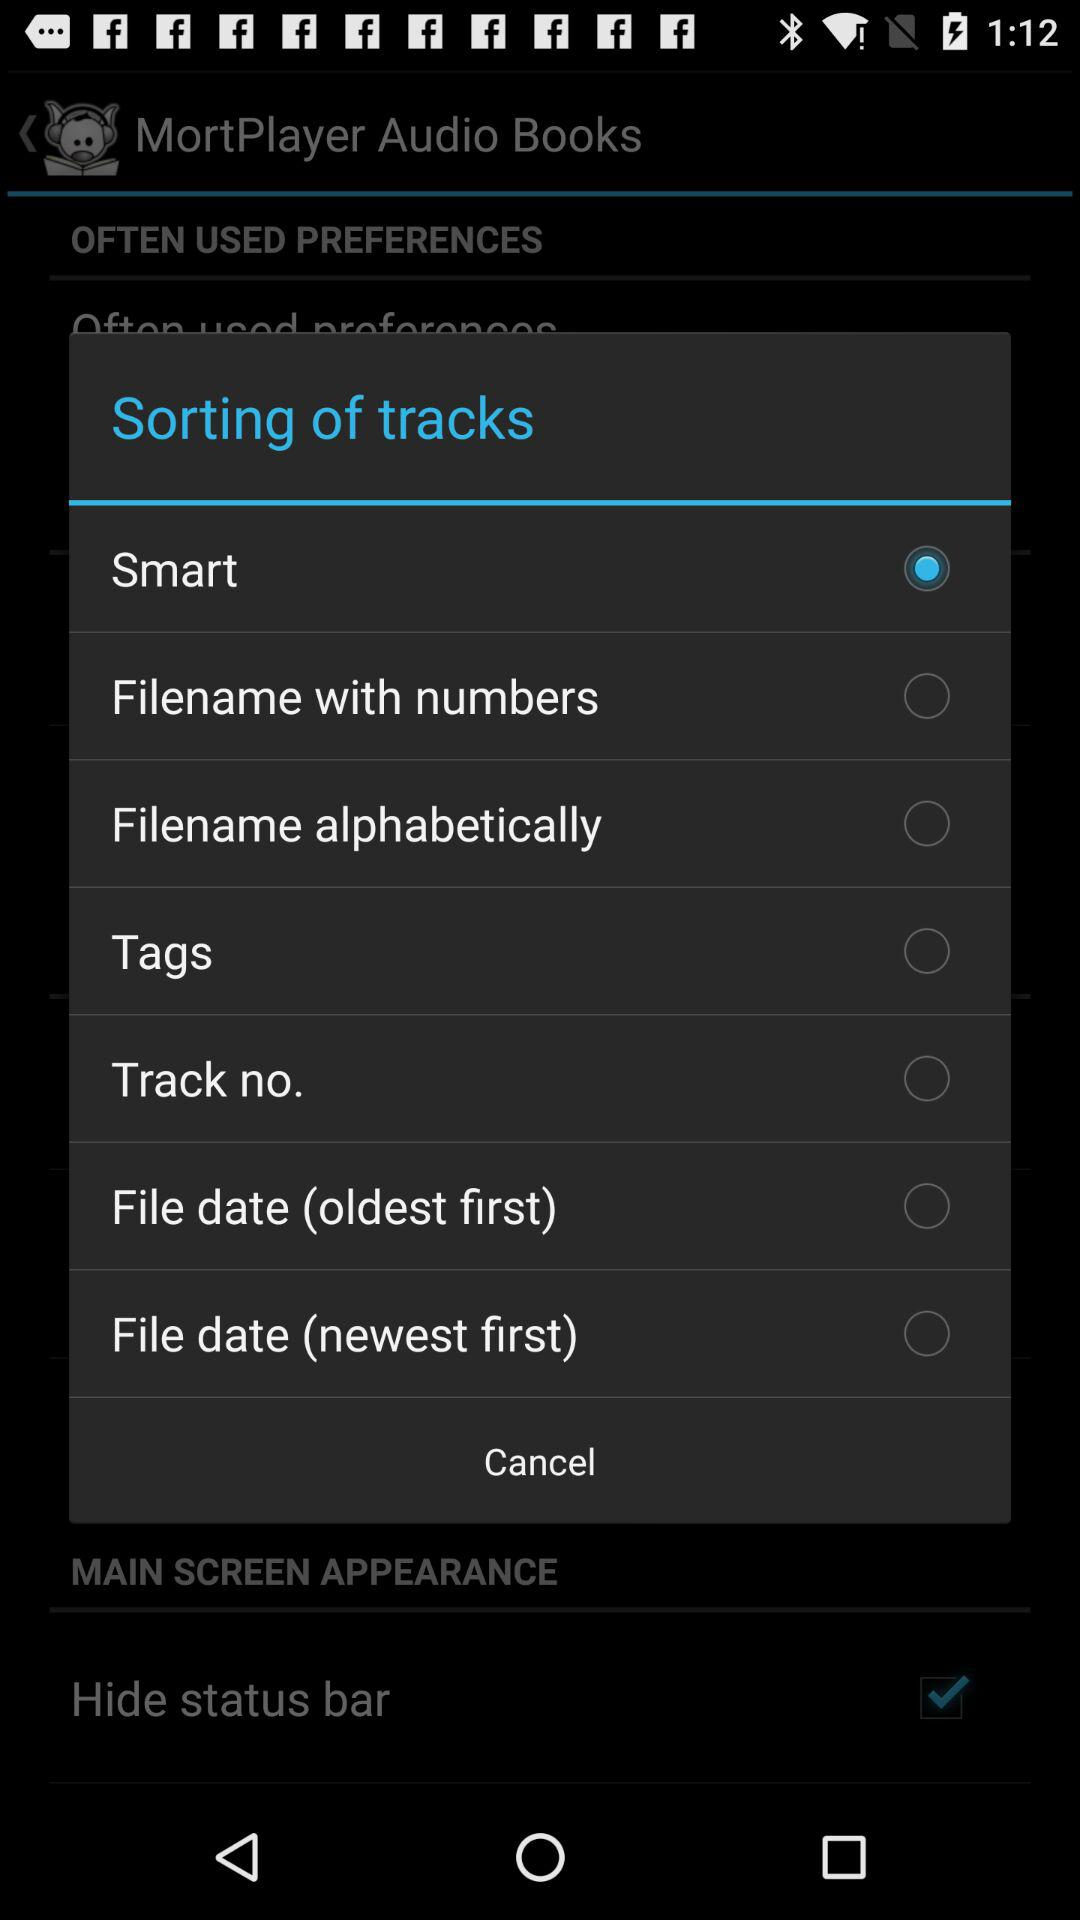Is "Smart" selected or not?
Answer the question using a single word or phrase. "Smart" is selected. 